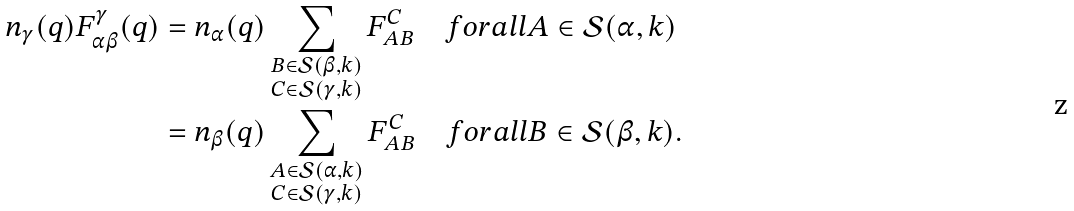<formula> <loc_0><loc_0><loc_500><loc_500>n _ { \gamma } ( q ) F _ { \alpha \beta } ^ { \gamma } ( q ) & = n _ { \alpha } ( q ) \sum _ { \substack { B \in \mathcal { S } ( \beta , k ) \\ C \in \mathcal { S } ( \gamma , k ) } } F _ { A B } ^ { C } \quad f o r a l l A \in \mathcal { S } ( \alpha , k ) \\ & = n _ { \beta } ( q ) \sum _ { \substack { A \in \mathcal { S } ( \alpha , k ) \\ C \in \mathcal { S } ( \gamma , k ) } } F _ { A B } ^ { C } \quad f o r a l l B \in \mathcal { S } ( \beta , k ) .</formula> 